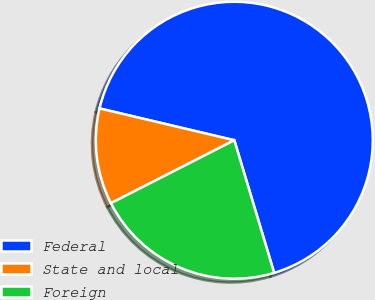Convert chart. <chart><loc_0><loc_0><loc_500><loc_500><pie_chart><fcel>Federal<fcel>State and local<fcel>Foreign<nl><fcel>66.67%<fcel>11.2%<fcel>22.14%<nl></chart> 